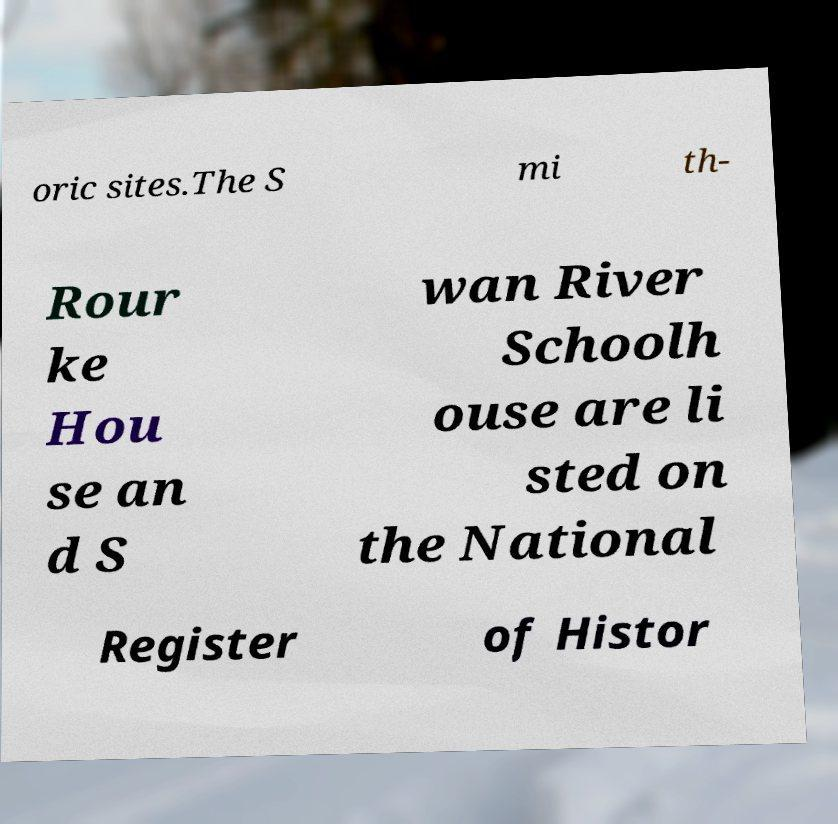There's text embedded in this image that I need extracted. Can you transcribe it verbatim? oric sites.The S mi th- Rour ke Hou se an d S wan River Schoolh ouse are li sted on the National Register of Histor 